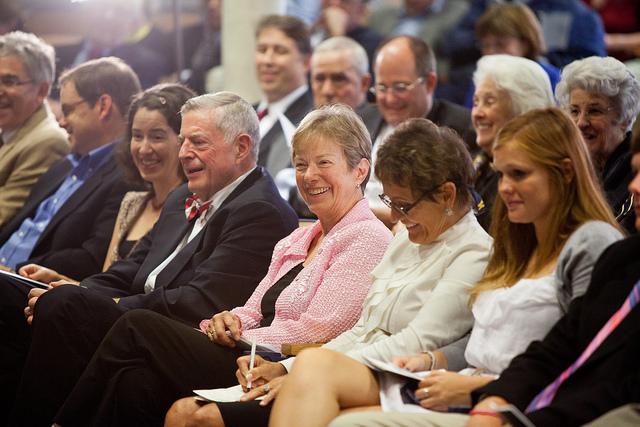What are the people in the foreground using?
Be succinct. Paper and pen. What color is the women's sweater?
Be succinct. Pink. Are all the people laughing?
Concise answer only. Yes. Is this a bad hair convention?
Short answer required. No. Where are the people in the photograph?
Concise answer only. Church. Are they outside?
Short answer required. No. Is this a graduation?
Concise answer only. No. What is in the ladies hand?
Be succinct. Pen. 